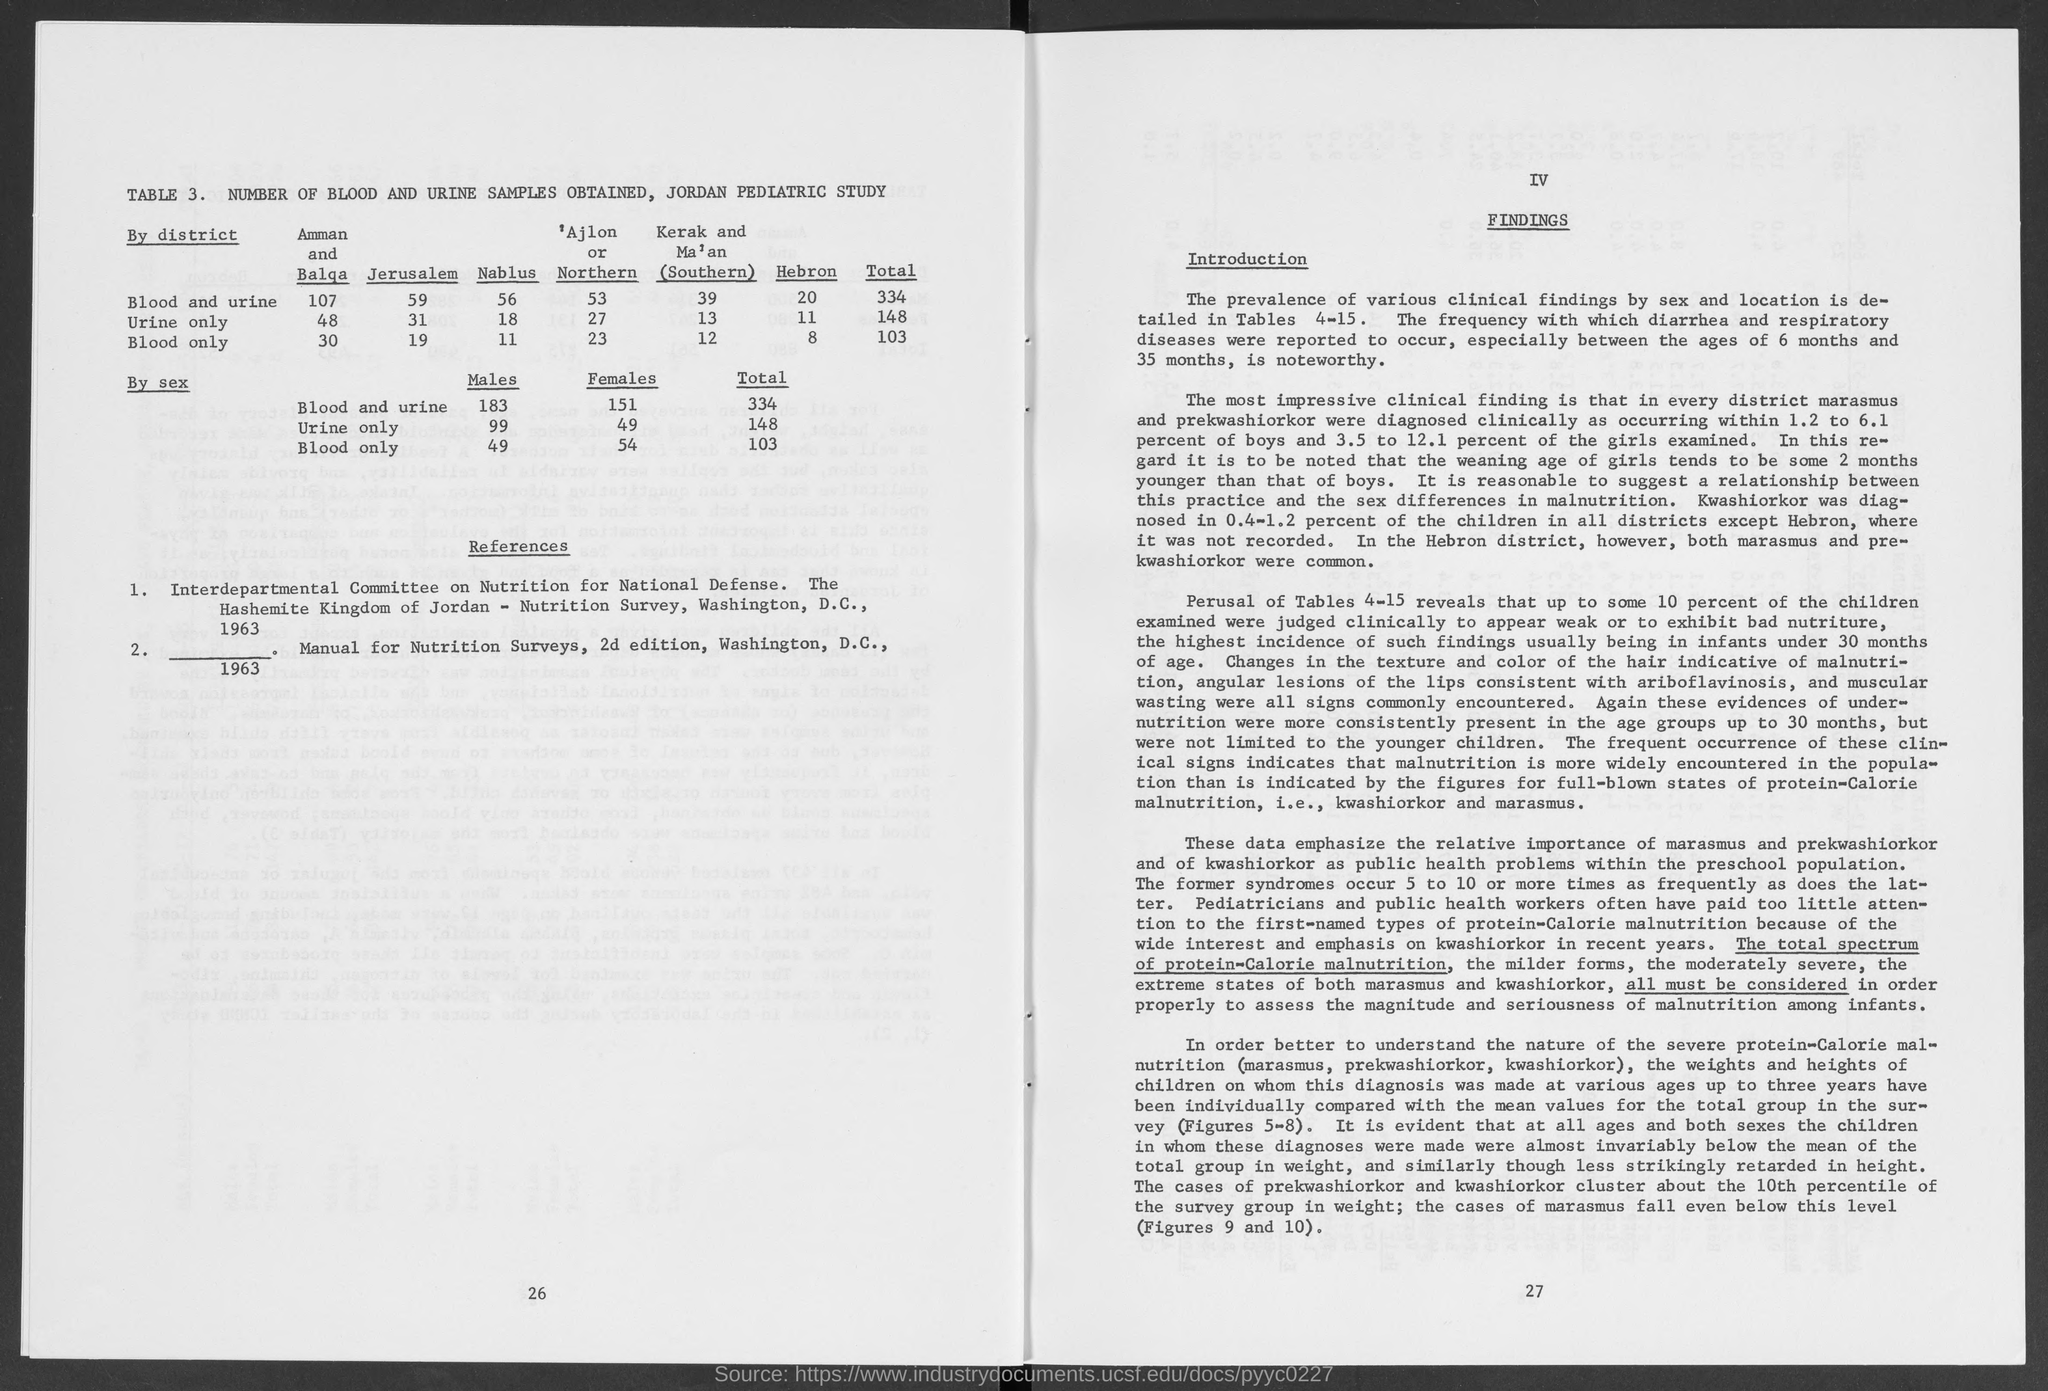List a handful of essential elements in this visual. The title of Table 3 in the Jordan Pediatric Study is 'Number of Blood and Urine Samples Obtained.' 